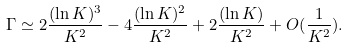Convert formula to latex. <formula><loc_0><loc_0><loc_500><loc_500>\Gamma \simeq 2 \frac { ( \ln K ) ^ { 3 } } { K ^ { 2 } } - 4 \frac { ( \ln K ) ^ { 2 } } { K ^ { 2 } } + 2 \frac { ( \ln K ) } { K ^ { 2 } } + O ( \frac { 1 } { K ^ { 2 } } ) .</formula> 